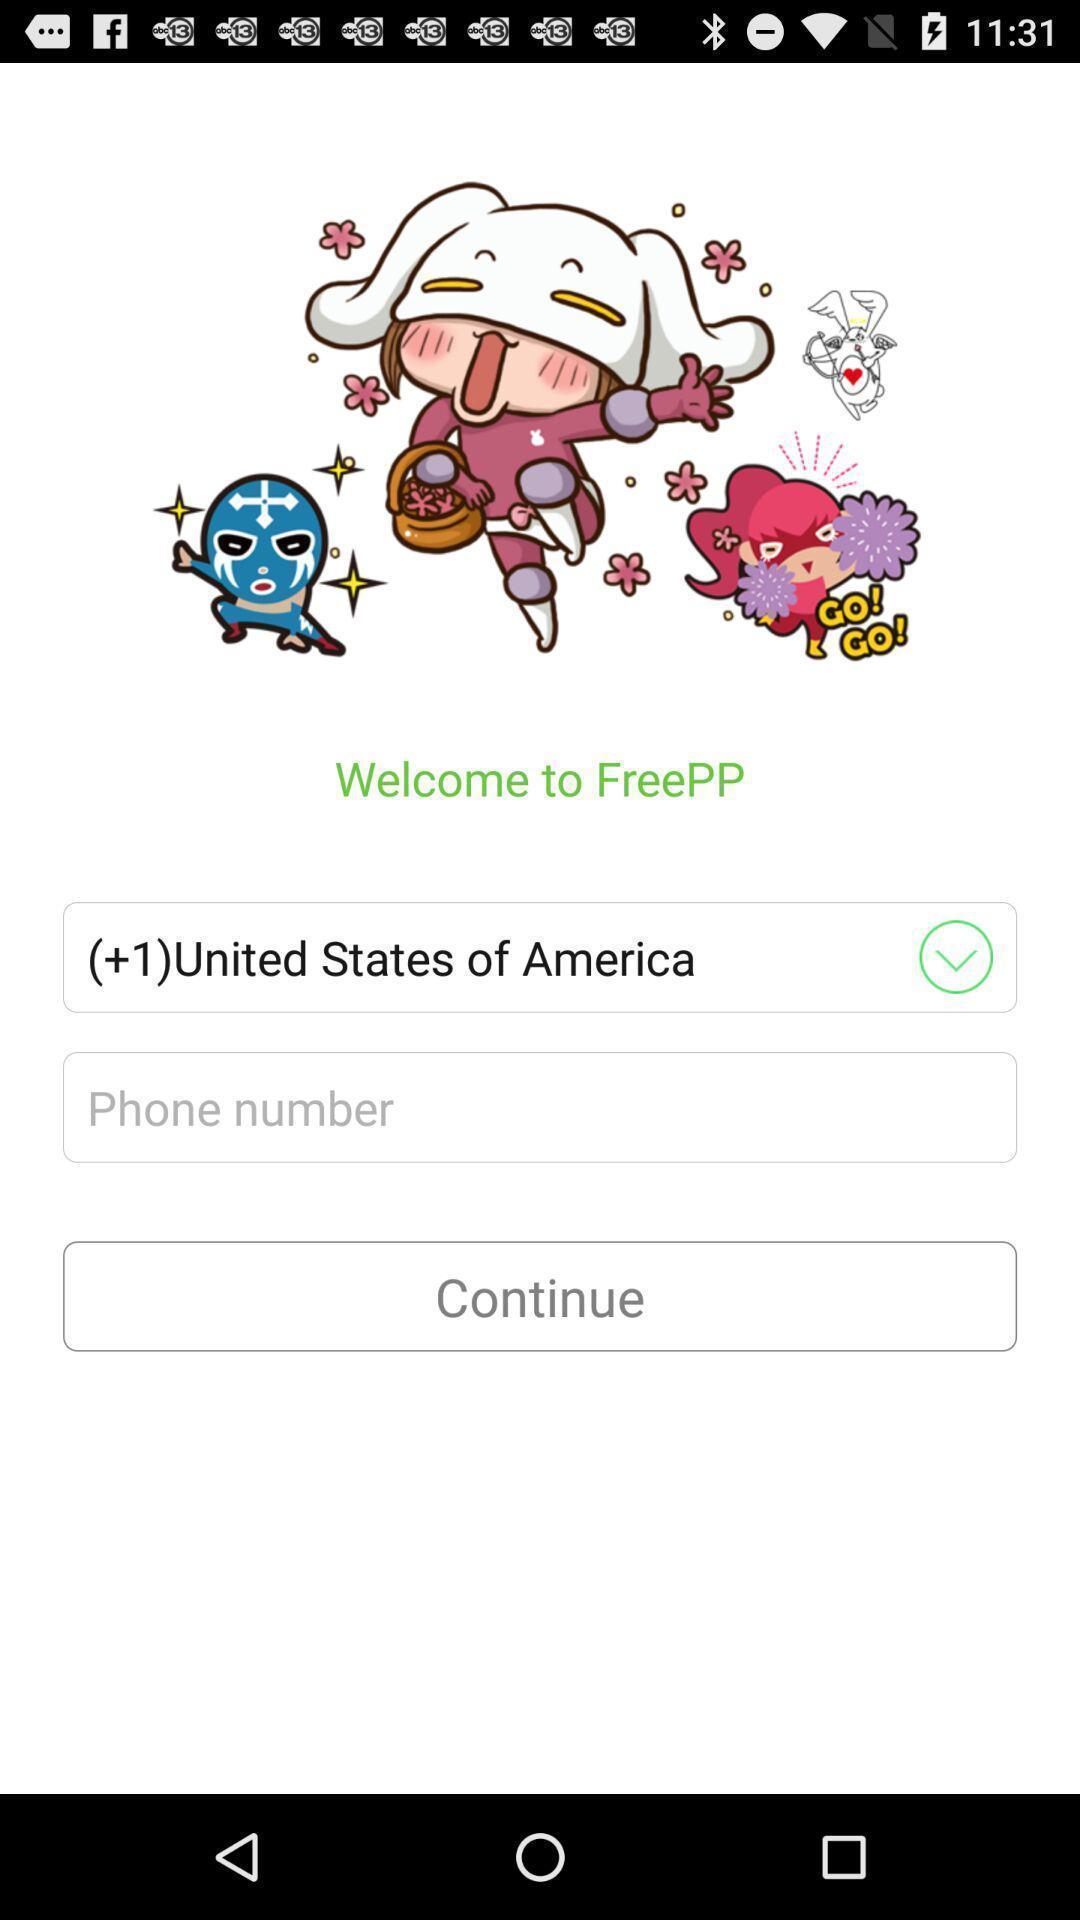Explain the elements present in this screenshot. Welcome page. 